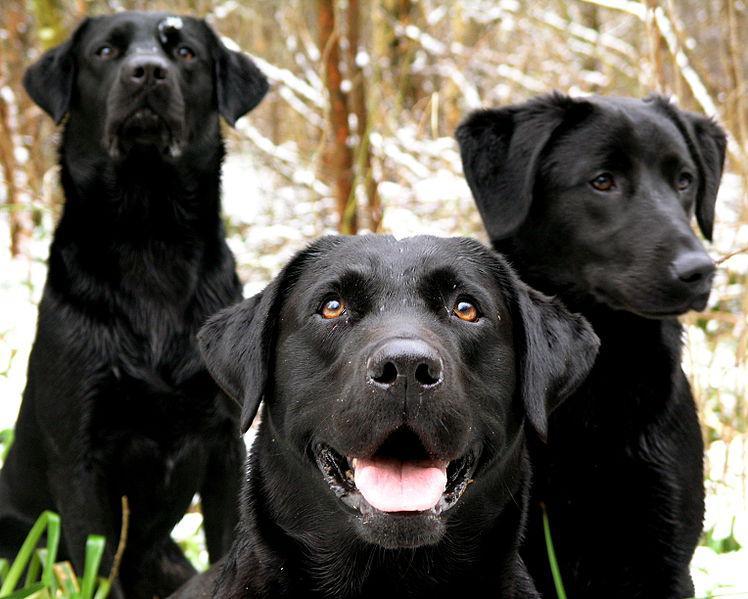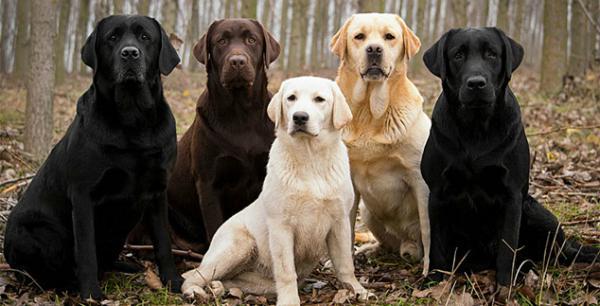The first image is the image on the left, the second image is the image on the right. Evaluate the accuracy of this statement regarding the images: "There is a white (or lighter-colored) dog sitting in between two darker colored dogs in each image". Is it true? Answer yes or no. No. 